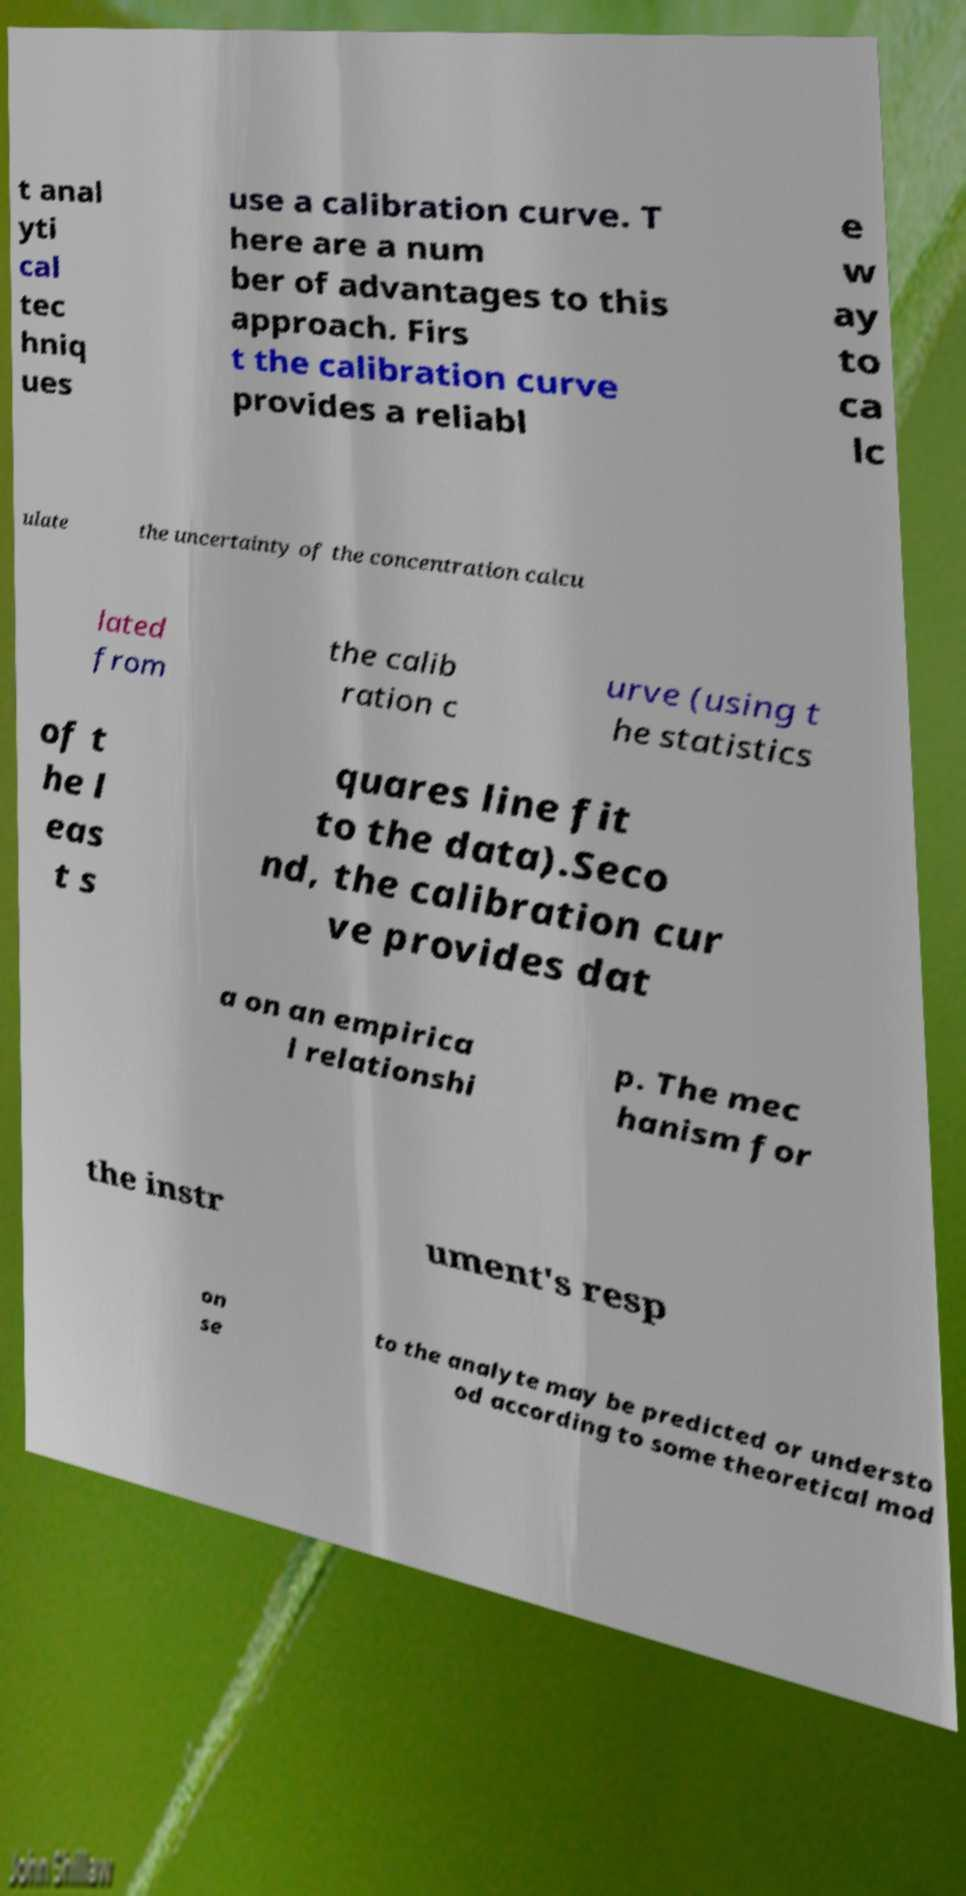What messages or text are displayed in this image? I need them in a readable, typed format. t anal yti cal tec hniq ues use a calibration curve. T here are a num ber of advantages to this approach. Firs t the calibration curve provides a reliabl e w ay to ca lc ulate the uncertainty of the concentration calcu lated from the calib ration c urve (using t he statistics of t he l eas t s quares line fit to the data).Seco nd, the calibration cur ve provides dat a on an empirica l relationshi p. The mec hanism for the instr ument's resp on se to the analyte may be predicted or understo od according to some theoretical mod 